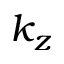Convert formula to latex. <formula><loc_0><loc_0><loc_500><loc_500>k _ { z }</formula> 